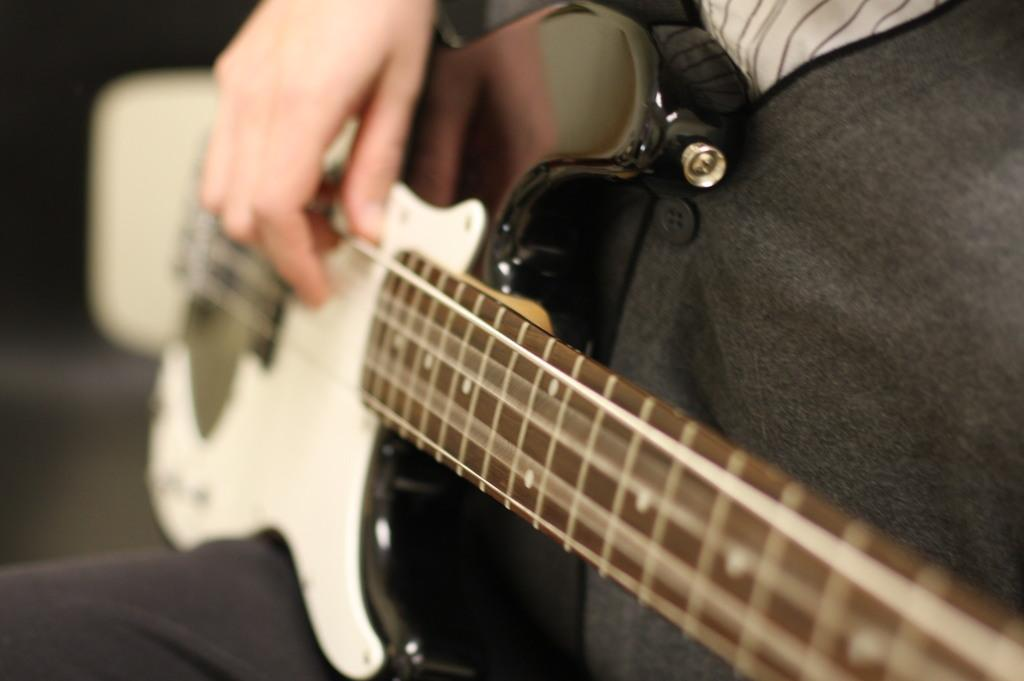What is the main subject of the image? There is a person in the image. What is the person wearing? The person is wearing a dress. What activity is the person engaged in? The person is playing a guitar. What type of bushes can be seen growing around the person in the image? There are no bushes visible in the image; it only features a person playing a guitar. What kind of produce is the person holding in the image? There is no produce present in the image; the person is holding a guitar. 